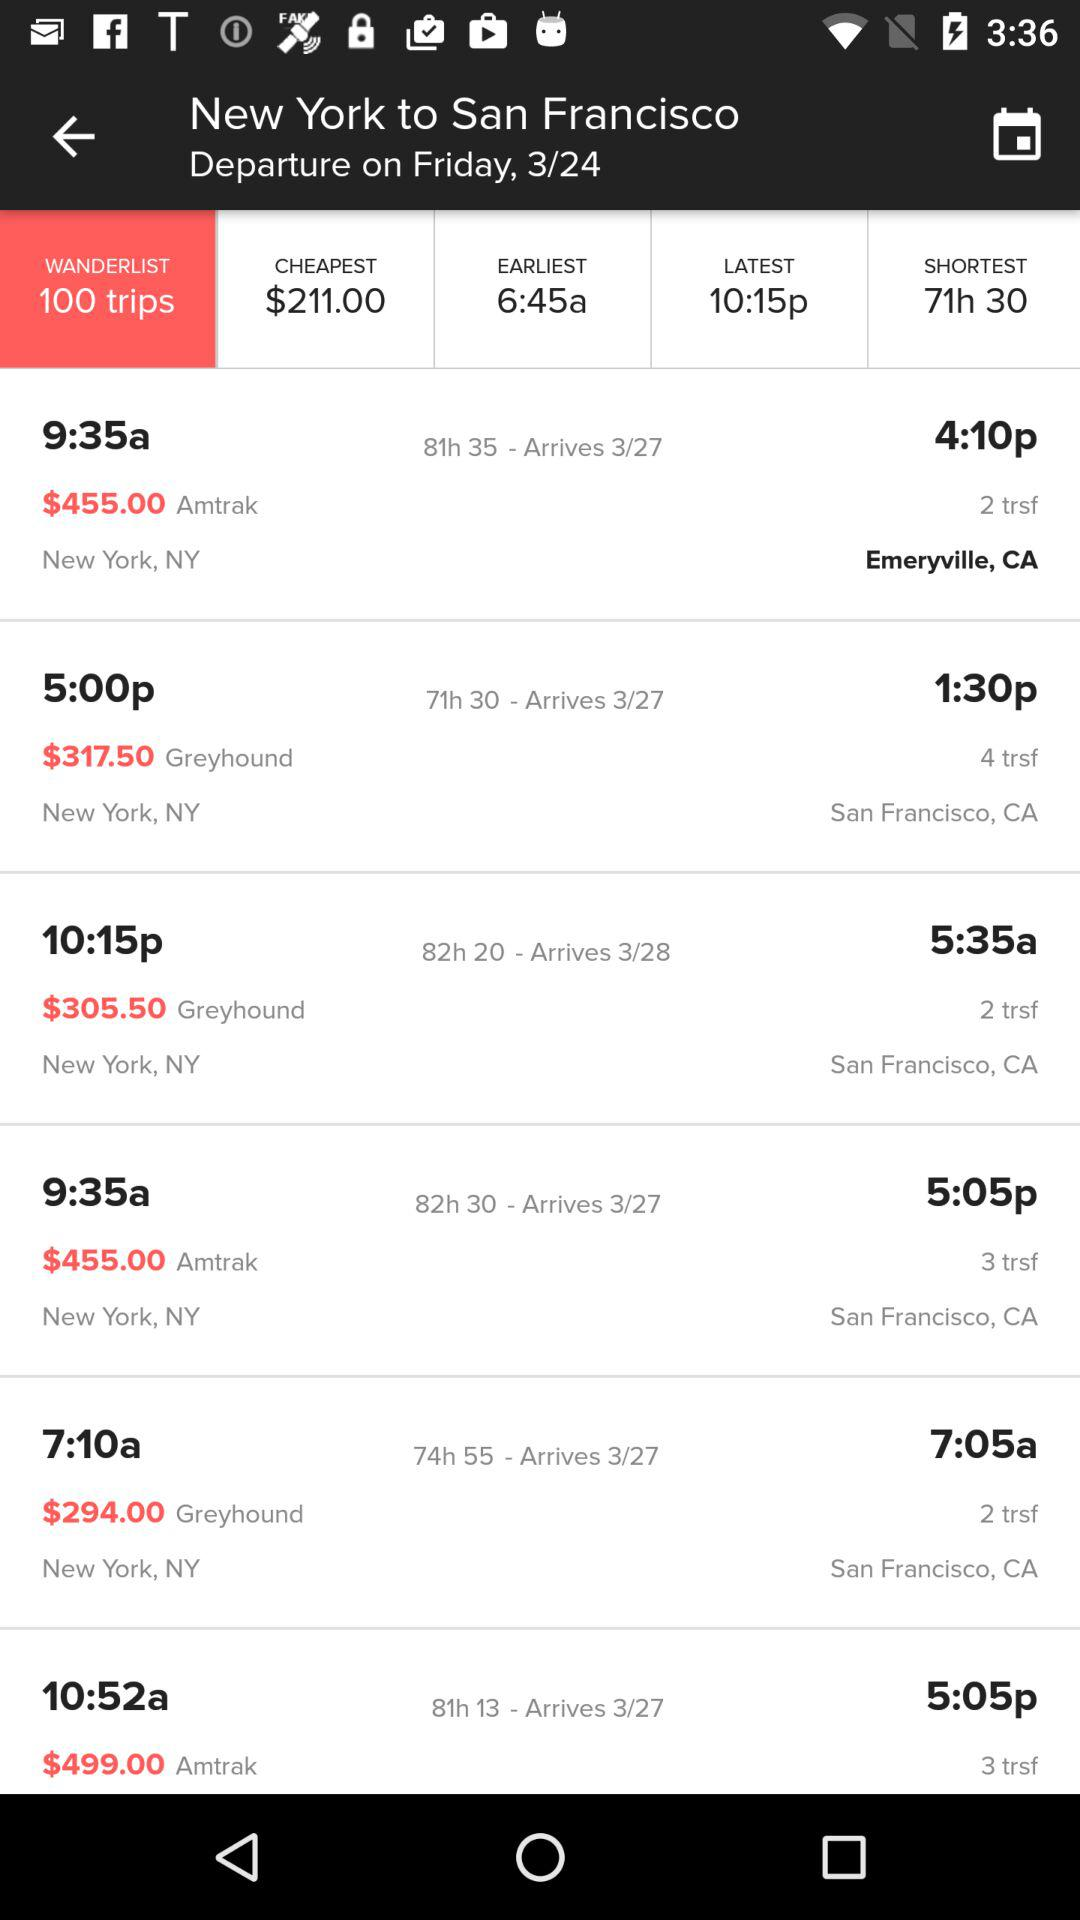Which option is selected? The selected option is "WANDERLIST 100 trips". 